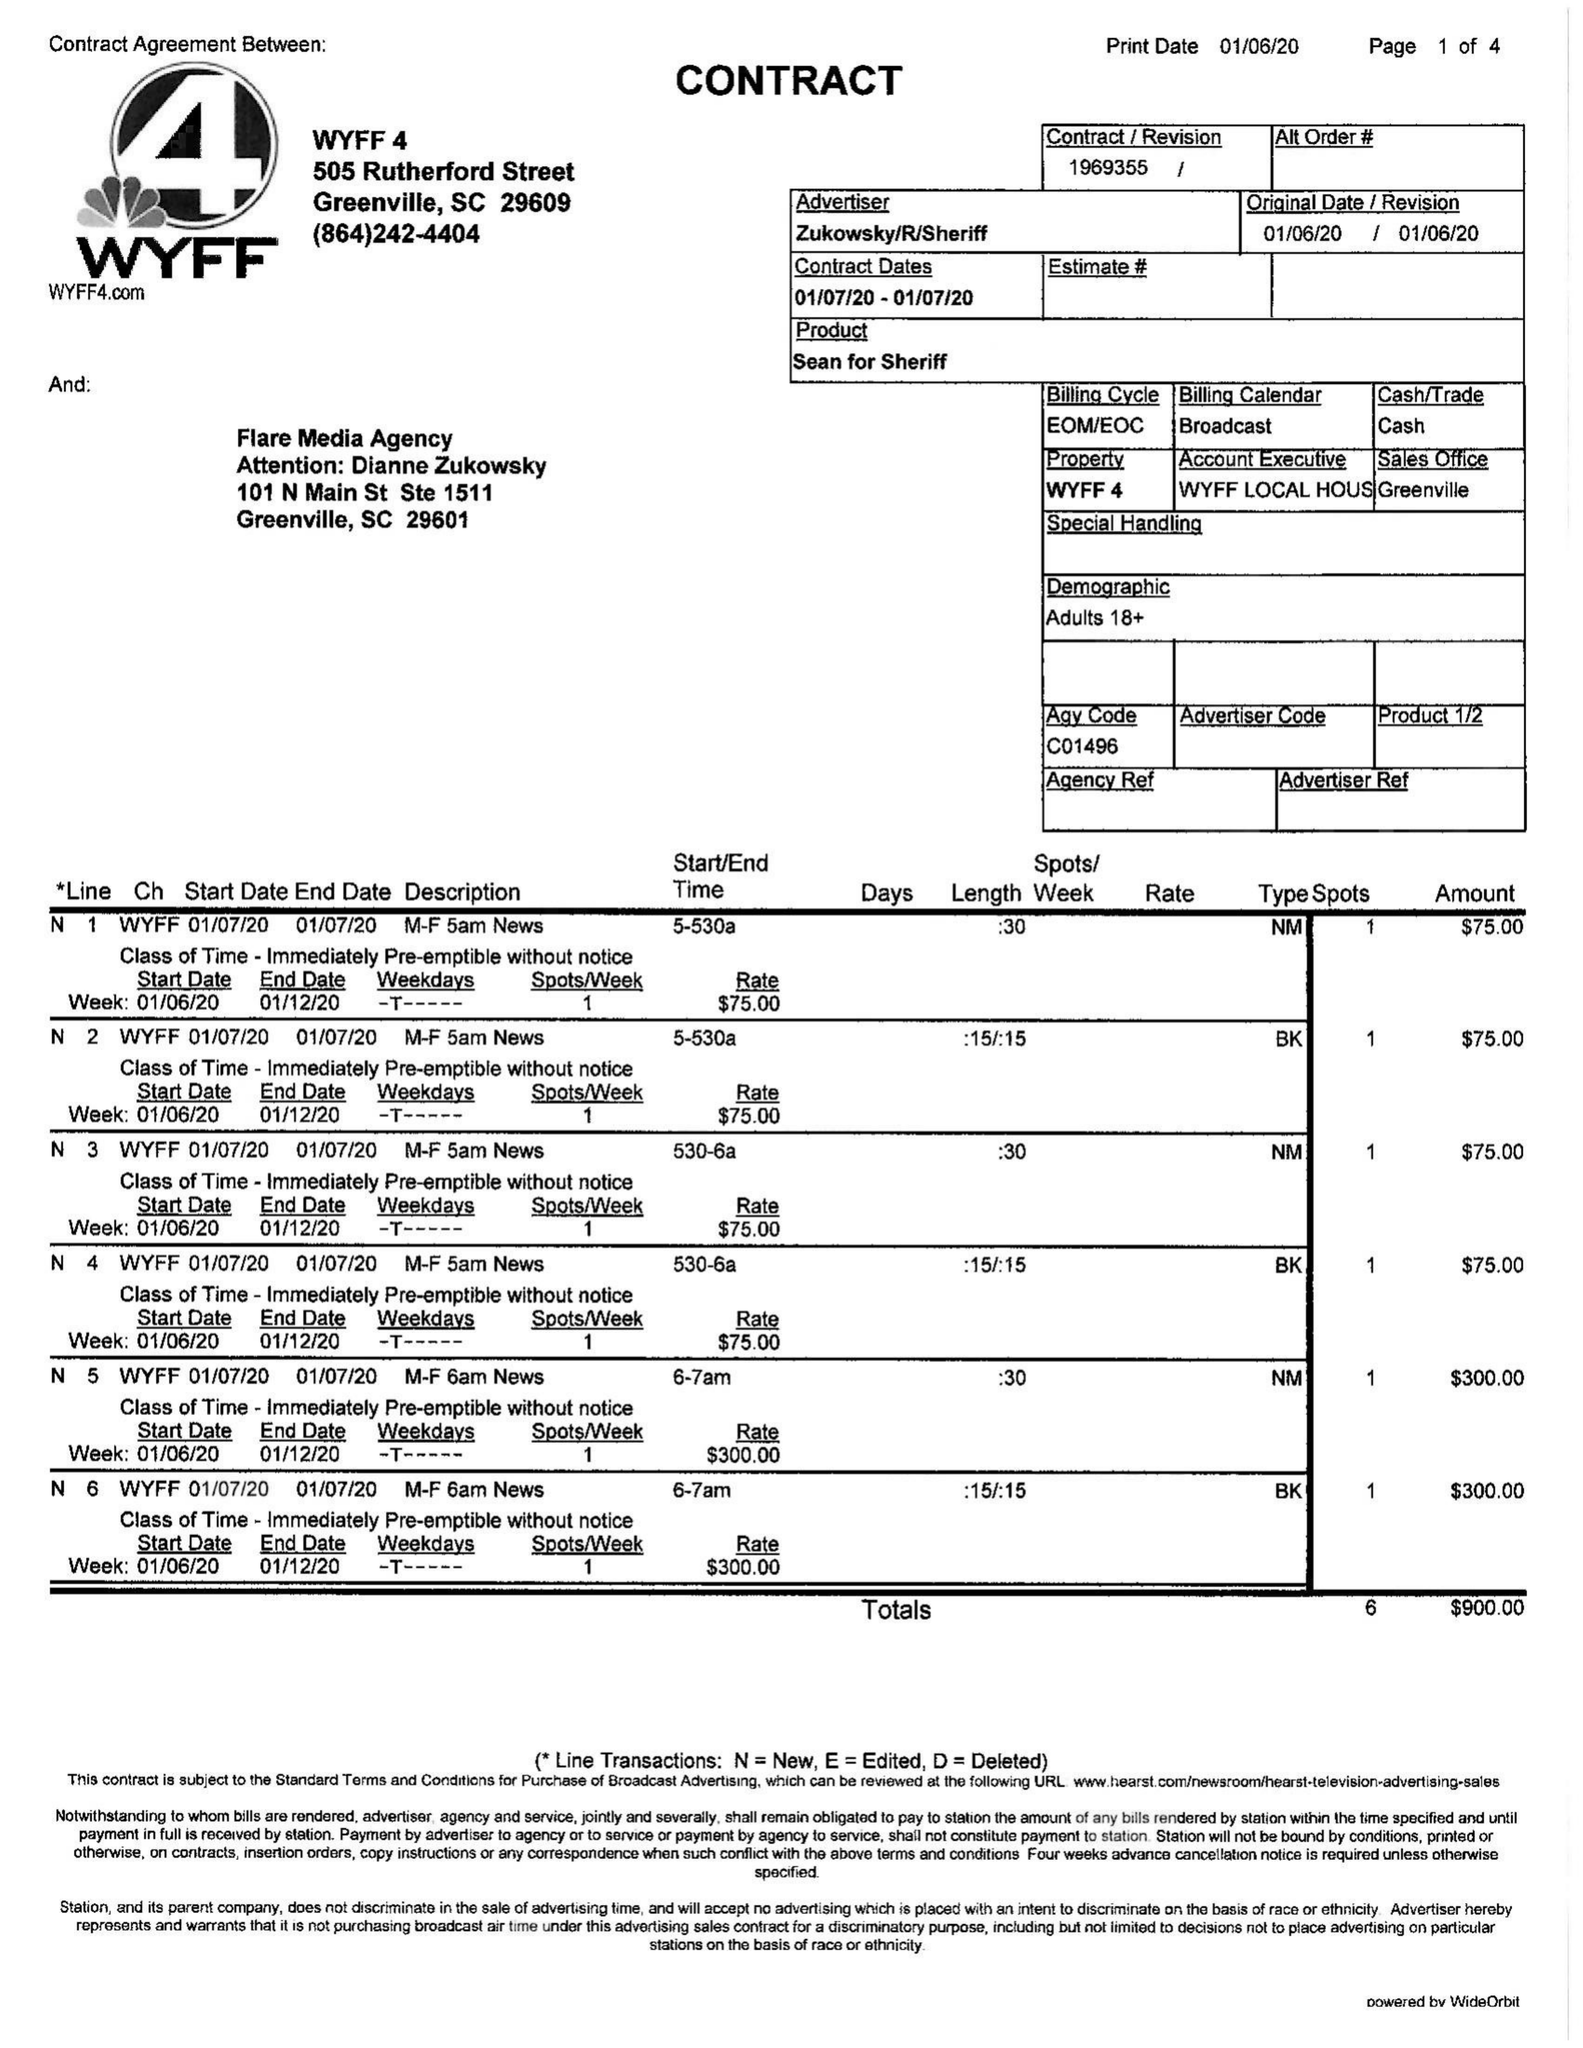What is the value for the flight_to?
Answer the question using a single word or phrase. 01/07/20 